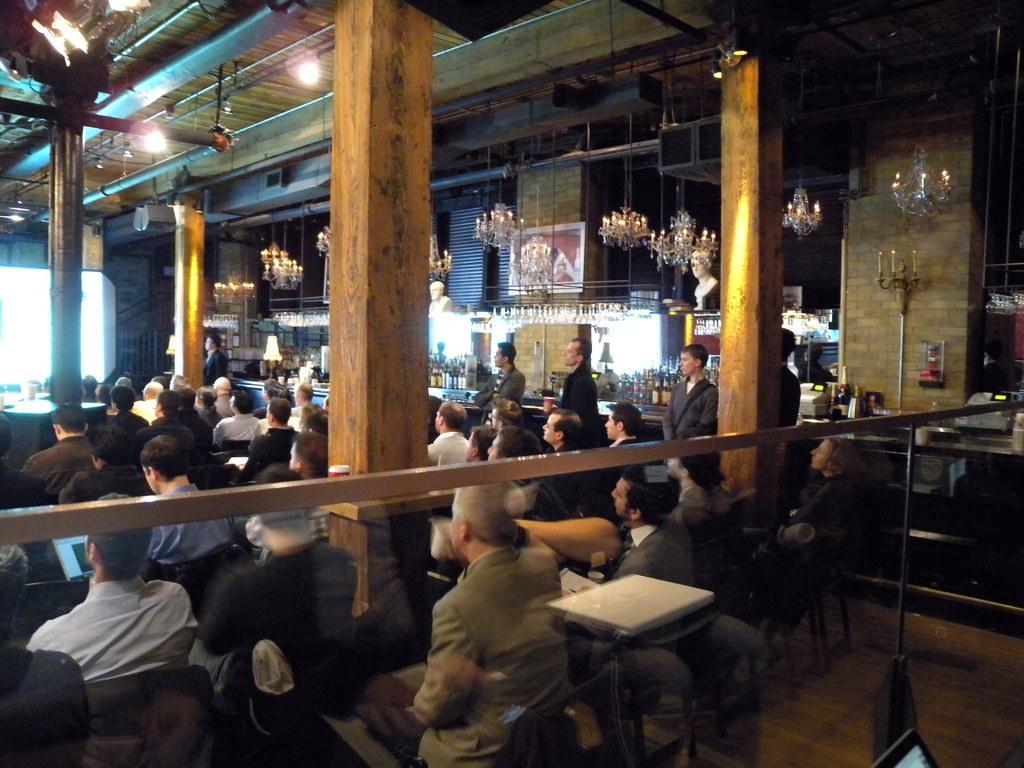Please provide a concise description of this image. In this picture I can see few people are sitting in the chairs and a man working on a laptop and I can see chandelier lights and few lights to the ceiling and few people are standing and it looks like a laptop on the table. 